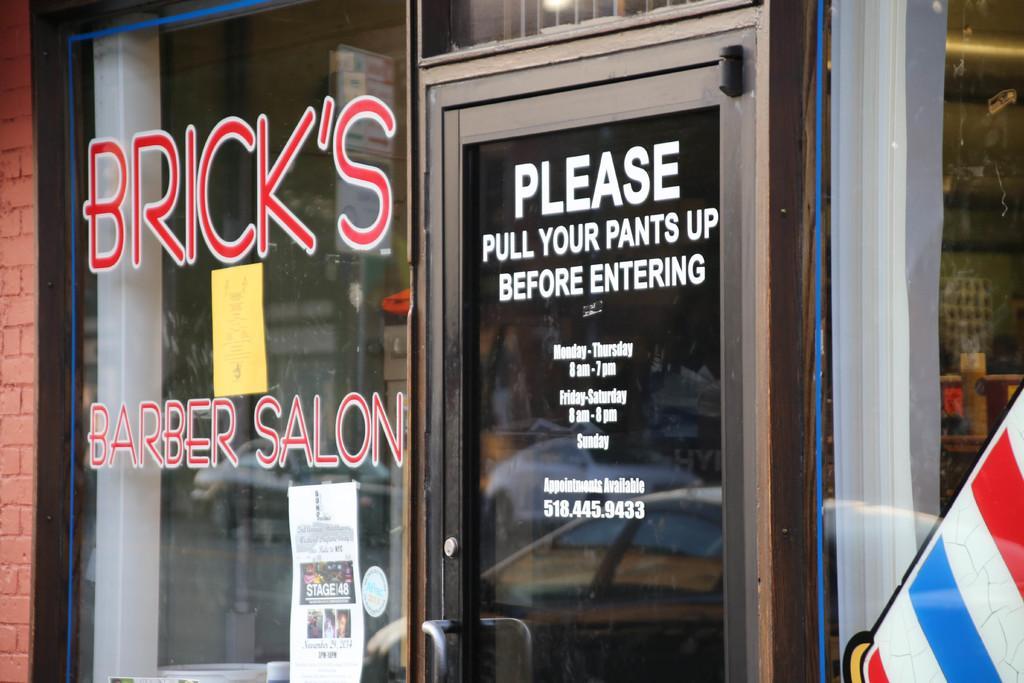In one or two sentences, can you explain what this image depicts? In this image we can see a door and some text on it. 